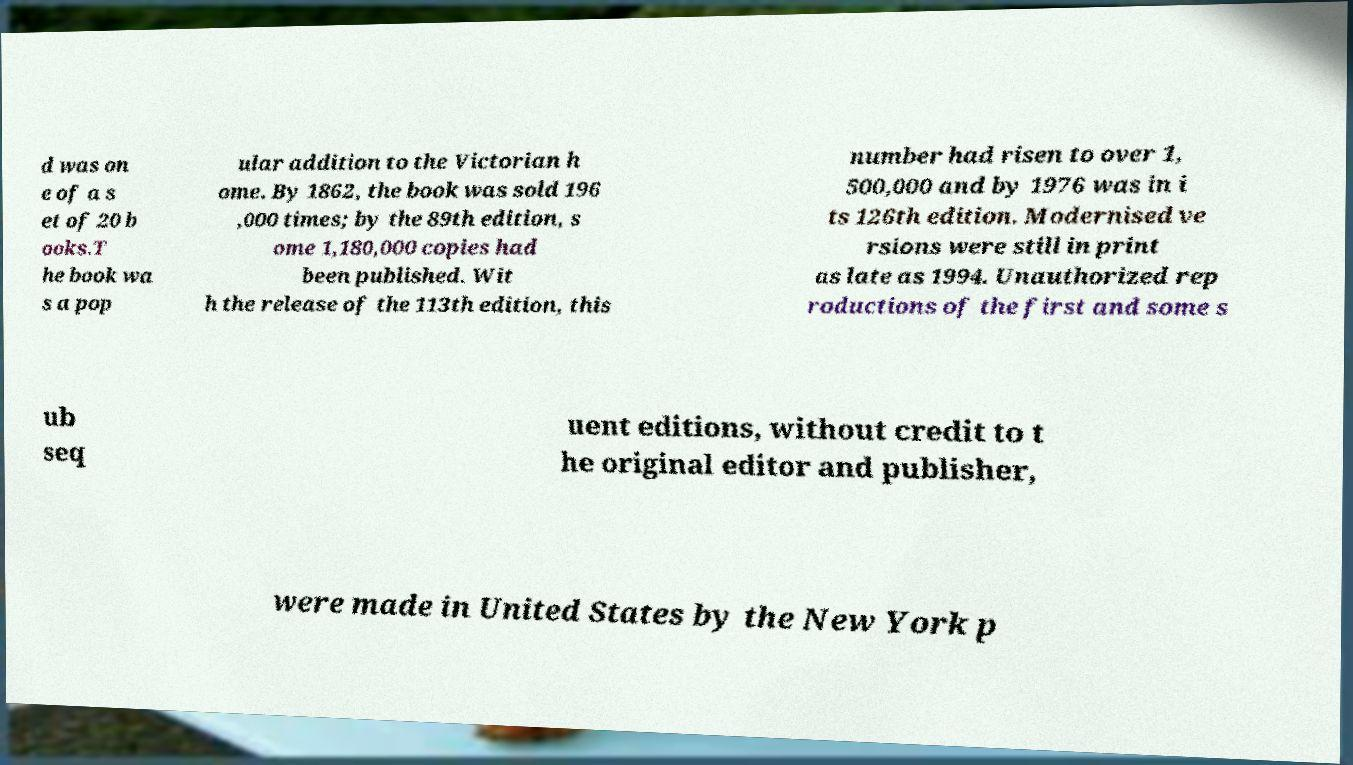For documentation purposes, I need the text within this image transcribed. Could you provide that? d was on e of a s et of 20 b ooks.T he book wa s a pop ular addition to the Victorian h ome. By 1862, the book was sold 196 ,000 times; by the 89th edition, s ome 1,180,000 copies had been published. Wit h the release of the 113th edition, this number had risen to over 1, 500,000 and by 1976 was in i ts 126th edition. Modernised ve rsions were still in print as late as 1994. Unauthorized rep roductions of the first and some s ub seq uent editions, without credit to t he original editor and publisher, were made in United States by the New York p 